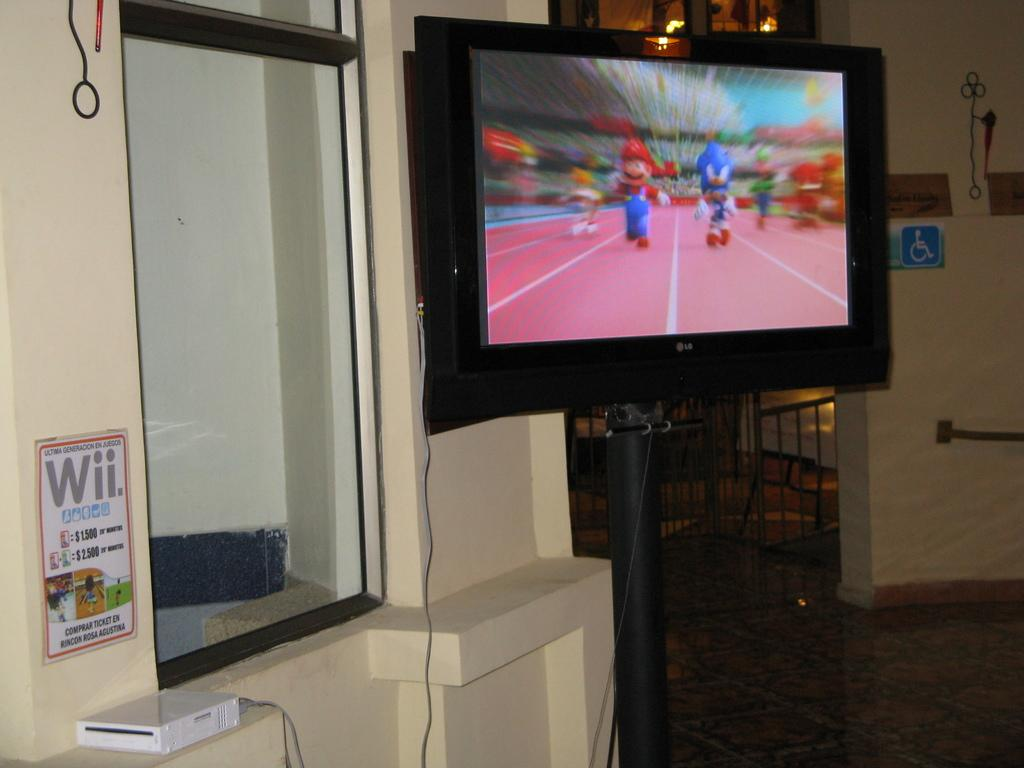<image>
Create a compact narrative representing the image presented. A flat screen TV made by LG has a Mario game on it and a sign nearby that says Wii. 